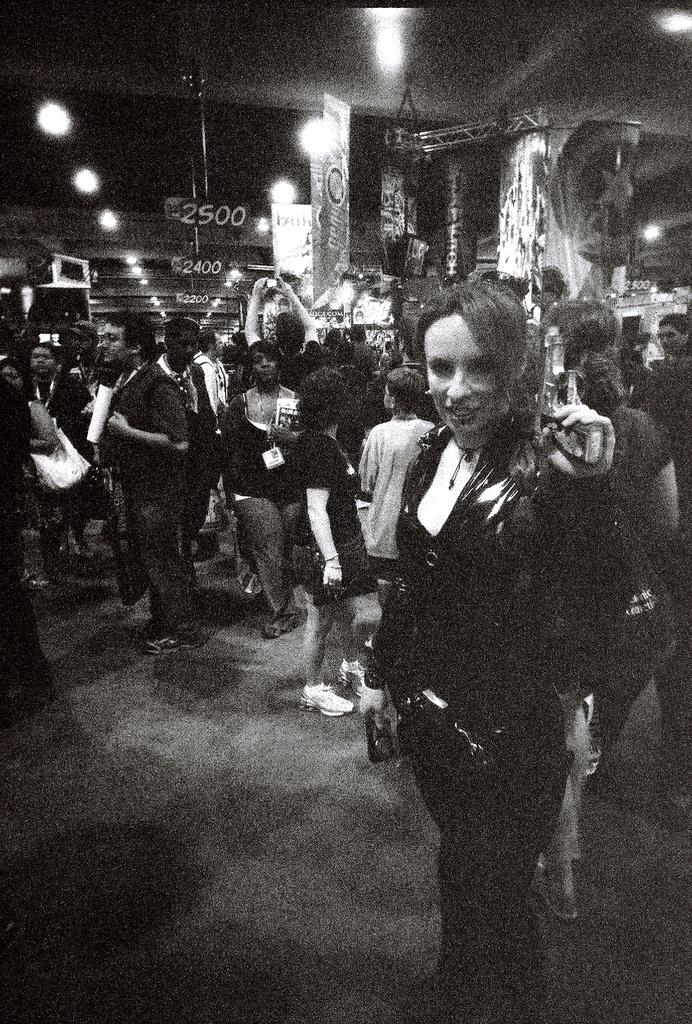What is the color scheme of the image? The image is black and white. What can be seen in the image besides the color scheme? There are people standing in the image. Where are the people standing? The people are standing on the floor. What type of lighting is present in the image? There are electric lights in the image. What objects are related to cooking in the image? There are grills in the image. What type of signs are present in the image? There are name boards in the image. What type of toys can be seen being played with in the image? There are no toys present in the image; it features people standing on the floor, electric lights, grills, and name boards. What type of journey are the people taking in the image? There is no indication of a journey in the image; it simply shows people standing on the floor. 